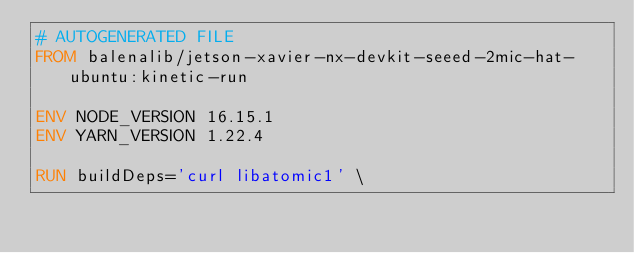Convert code to text. <code><loc_0><loc_0><loc_500><loc_500><_Dockerfile_># AUTOGENERATED FILE
FROM balenalib/jetson-xavier-nx-devkit-seeed-2mic-hat-ubuntu:kinetic-run

ENV NODE_VERSION 16.15.1
ENV YARN_VERSION 1.22.4

RUN buildDeps='curl libatomic1' \</code> 